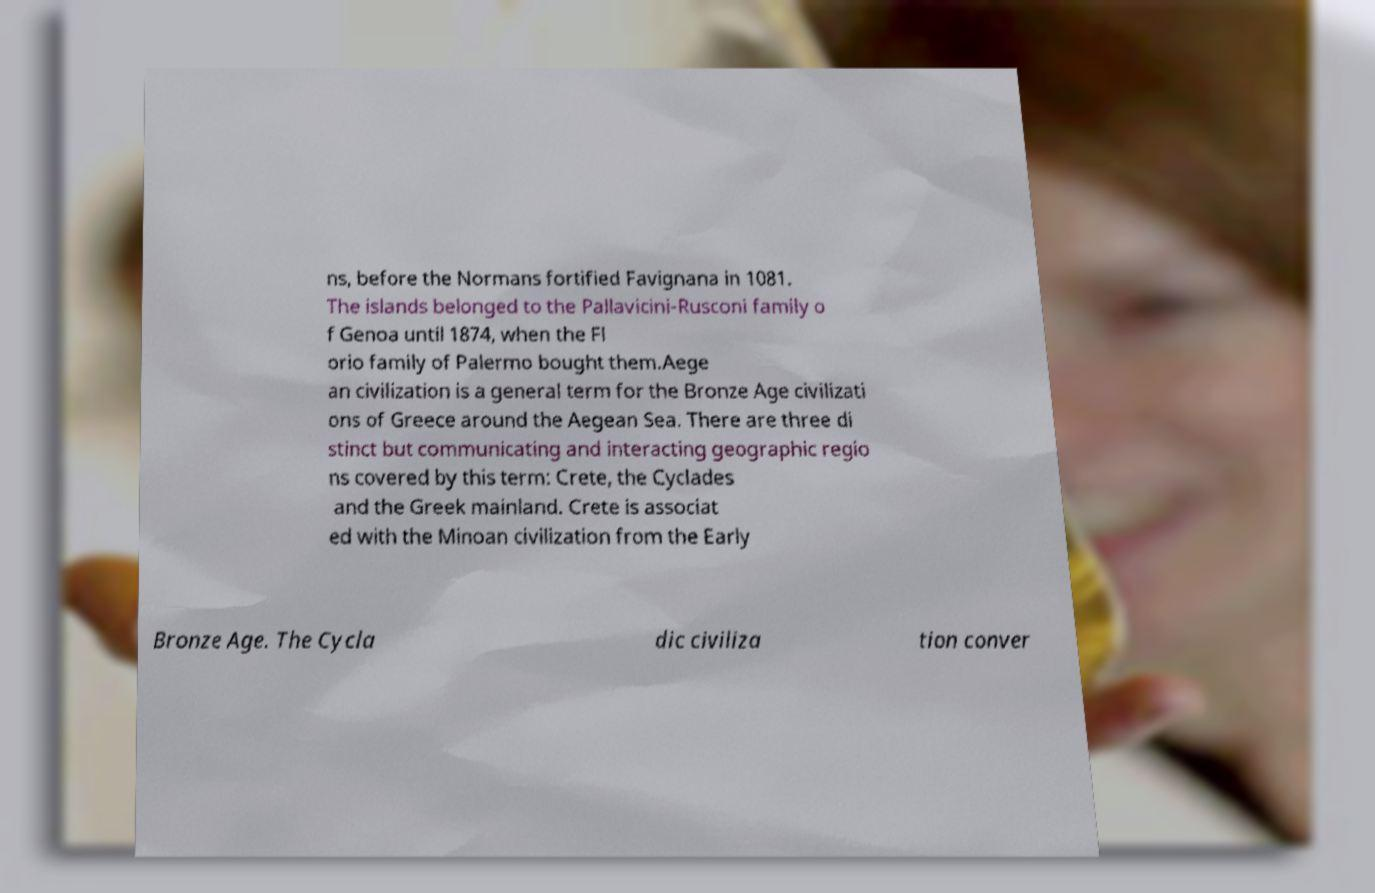Please identify and transcribe the text found in this image. ns, before the Normans fortified Favignana in 1081. The islands belonged to the Pallavicini-Rusconi family o f Genoa until 1874, when the Fl orio family of Palermo bought them.Aege an civilization is a general term for the Bronze Age civilizati ons of Greece around the Aegean Sea. There are three di stinct but communicating and interacting geographic regio ns covered by this term: Crete, the Cyclades and the Greek mainland. Crete is associat ed with the Minoan civilization from the Early Bronze Age. The Cycla dic civiliza tion conver 